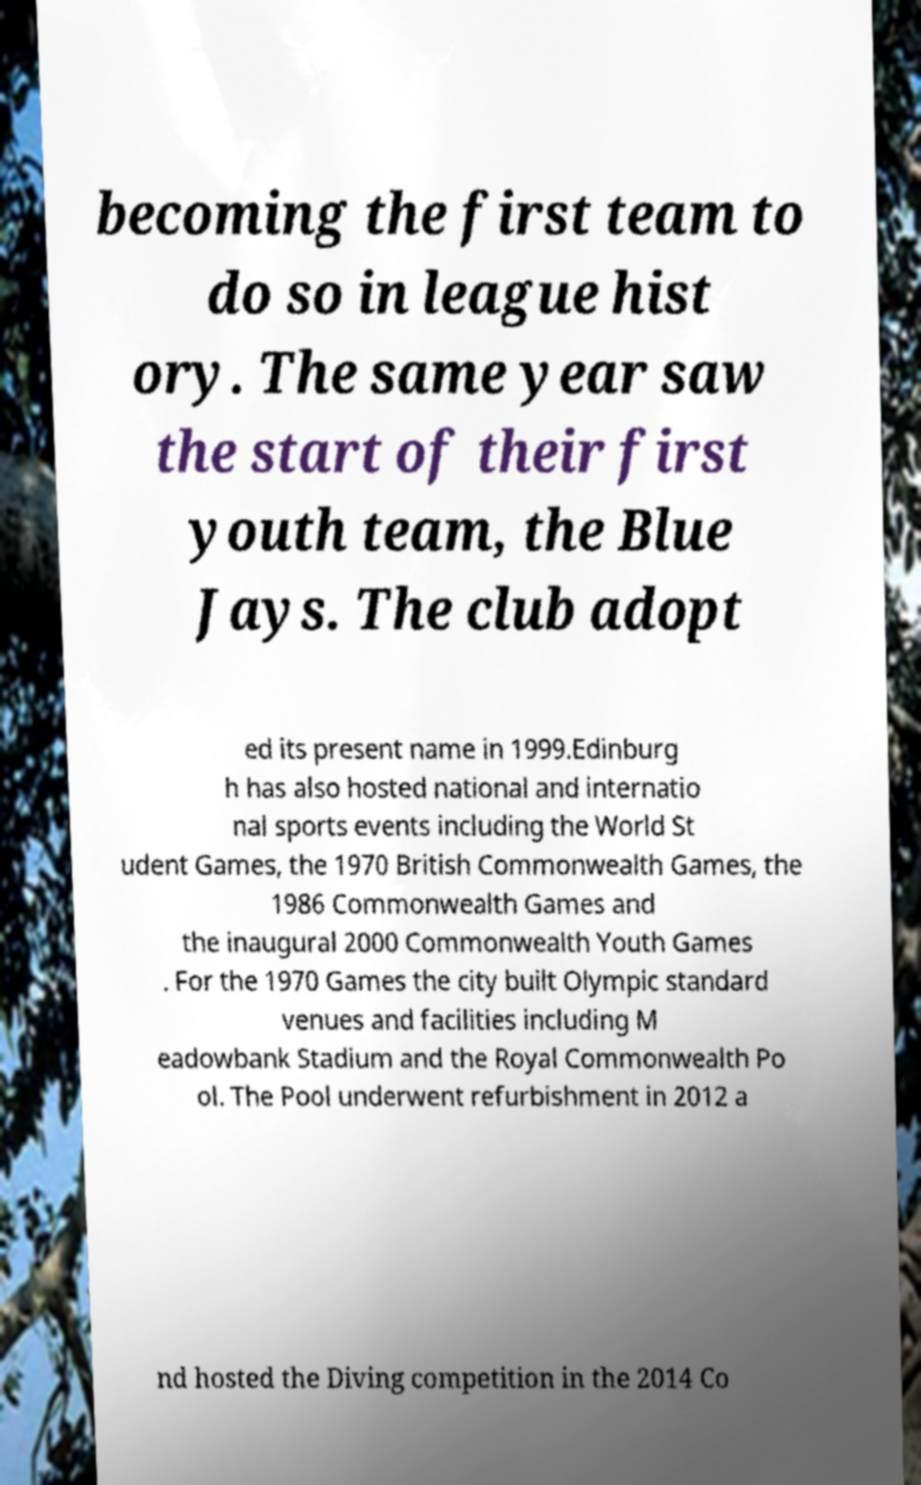Can you accurately transcribe the text from the provided image for me? becoming the first team to do so in league hist ory. The same year saw the start of their first youth team, the Blue Jays. The club adopt ed its present name in 1999.Edinburg h has also hosted national and internatio nal sports events including the World St udent Games, the 1970 British Commonwealth Games, the 1986 Commonwealth Games and the inaugural 2000 Commonwealth Youth Games . For the 1970 Games the city built Olympic standard venues and facilities including M eadowbank Stadium and the Royal Commonwealth Po ol. The Pool underwent refurbishment in 2012 a nd hosted the Diving competition in the 2014 Co 